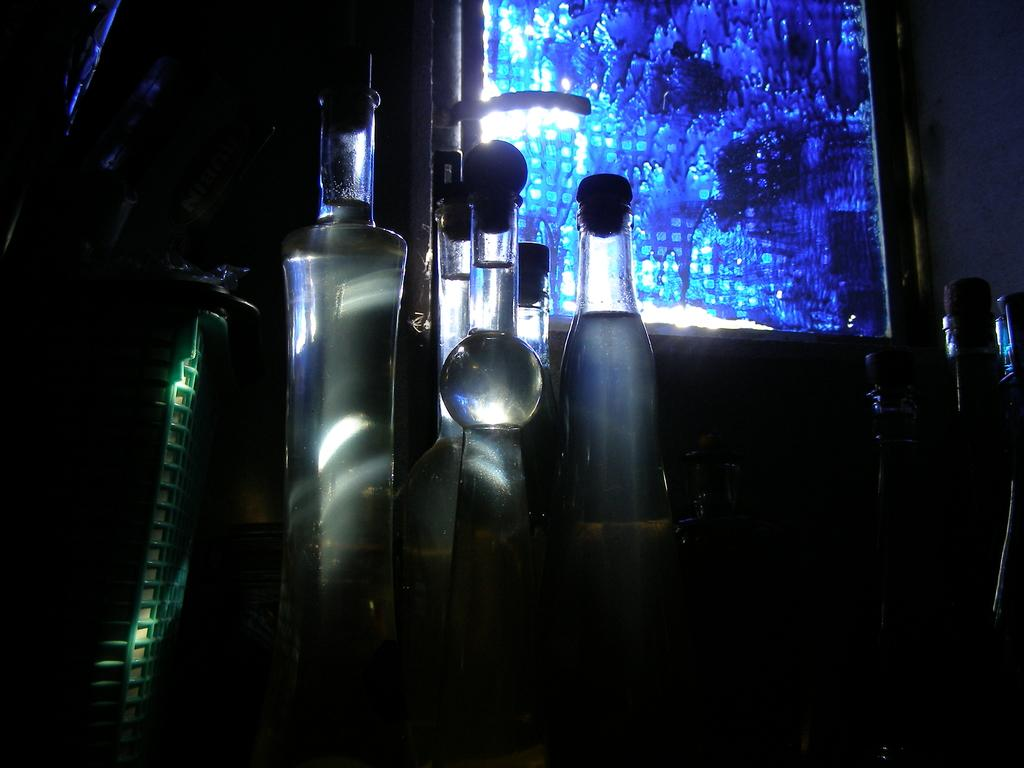What objects can be seen in the image? There are bottles in the image. Is there an umbrella being used to hold the bottles in the image? There is no mention of an umbrella in the image, and it is not visible in the provided facts. 